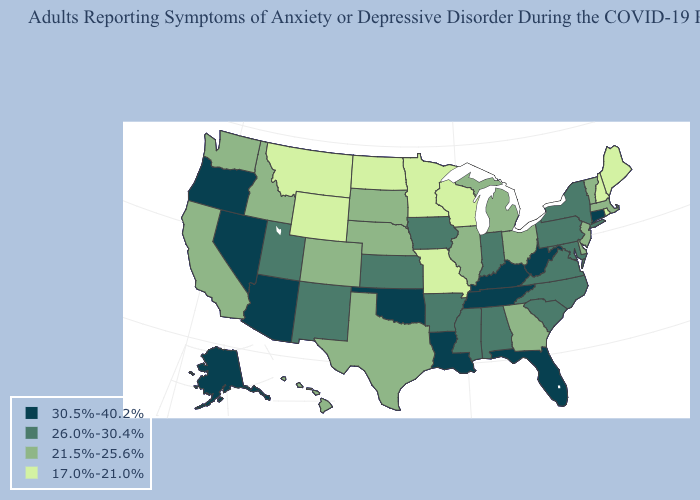Does Rhode Island have a lower value than Washington?
Write a very short answer. Yes. What is the highest value in the USA?
Write a very short answer. 30.5%-40.2%. Does the map have missing data?
Answer briefly. No. What is the value of South Dakota?
Short answer required. 21.5%-25.6%. What is the value of Illinois?
Keep it brief. 21.5%-25.6%. What is the value of Vermont?
Concise answer only. 21.5%-25.6%. What is the value of Virginia?
Quick response, please. 26.0%-30.4%. What is the value of North Carolina?
Keep it brief. 26.0%-30.4%. Does Oklahoma have the highest value in the USA?
Be succinct. Yes. What is the value of North Carolina?
Answer briefly. 26.0%-30.4%. How many symbols are there in the legend?
Answer briefly. 4. Name the states that have a value in the range 21.5%-25.6%?
Write a very short answer. California, Colorado, Delaware, Georgia, Hawaii, Idaho, Illinois, Massachusetts, Michigan, Nebraska, New Jersey, Ohio, South Dakota, Texas, Vermont, Washington. Name the states that have a value in the range 17.0%-21.0%?
Write a very short answer. Maine, Minnesota, Missouri, Montana, New Hampshire, North Dakota, Rhode Island, Wisconsin, Wyoming. Does Washington have a higher value than Minnesota?
Quick response, please. Yes. Name the states that have a value in the range 17.0%-21.0%?
Quick response, please. Maine, Minnesota, Missouri, Montana, New Hampshire, North Dakota, Rhode Island, Wisconsin, Wyoming. 